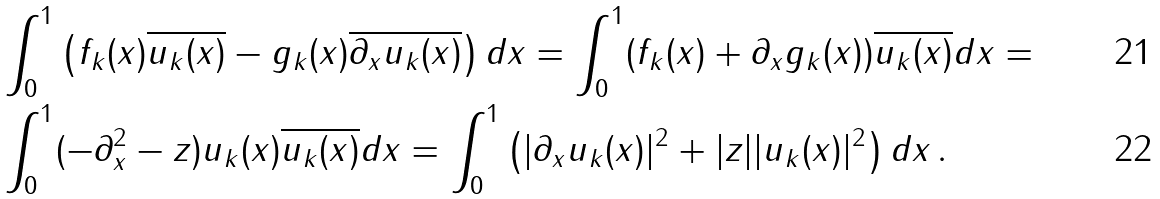Convert formula to latex. <formula><loc_0><loc_0><loc_500><loc_500>& \int _ { 0 } ^ { 1 } \left ( f _ { k } ( x ) \overline { u _ { k } ( x ) } - g _ { k } ( x ) \overline { \partial _ { x } u _ { k } ( x ) } \right ) d x = \int _ { 0 } ^ { 1 } ( f _ { k } ( x ) + \partial _ { x } g _ { k } ( x ) ) \overline { u _ { k } ( x ) } d x = \\ & \int _ { 0 } ^ { 1 } ( - \partial ^ { 2 } _ { x } - z ) u _ { k } ( x ) \overline { u _ { k } ( x ) } d x = \int _ { 0 } ^ { 1 } \left ( | \partial _ { x } u _ { k } ( x ) | ^ { 2 } + | z | | u _ { k } ( x ) | ^ { 2 } \right ) d x \, .</formula> 